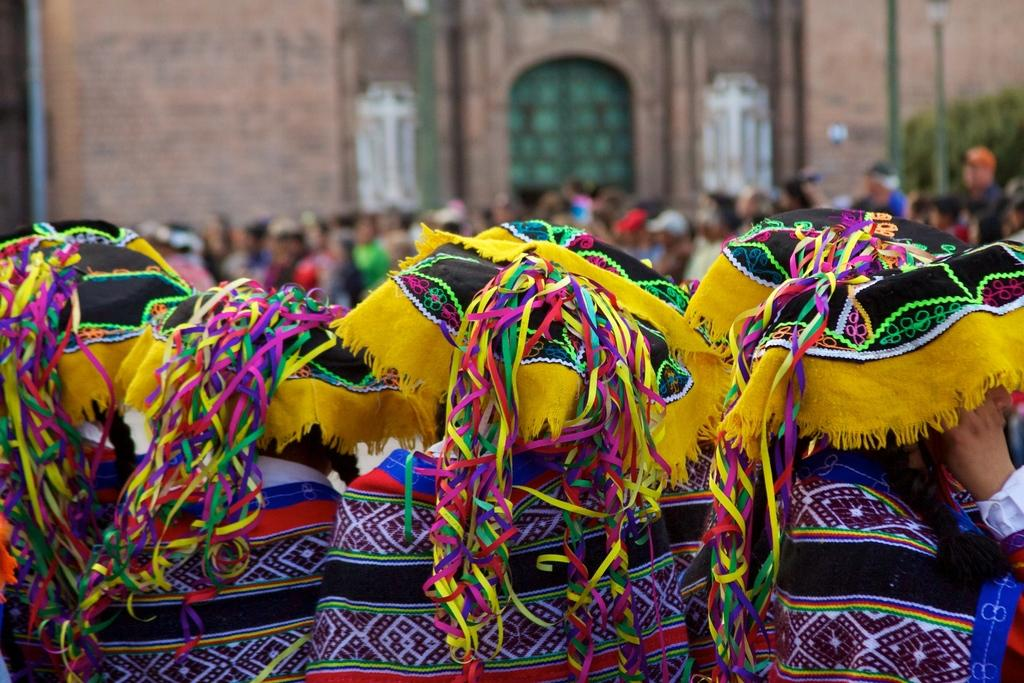How many persons are in the image? There are persons in the image, but the exact number is not specified. What are some of the persons wearing? Some of the persons are wearing costumes. What type of structure can be seen in the image? There is a building in the image. What other objects are present in the image? There are poles and plants in the image. How would you describe the background of the image? The background of the image is blurred. What type of winter activity is being performed by the persons in the image? There is no indication of winter or any winter activities in the image. What is the thing that the persons are holding in the image? The facts do not mention any specific thing being held by the persons in the image. How many twigs can be seen in the image? The facts do not mention any twigs in the image. 